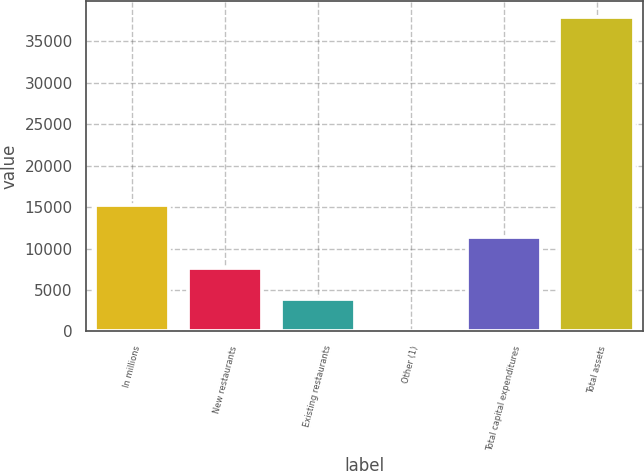Convert chart. <chart><loc_0><loc_0><loc_500><loc_500><bar_chart><fcel>In millions<fcel>New restaurants<fcel>Existing restaurants<fcel>Other (1)<fcel>Total capital expenditures<fcel>Total assets<nl><fcel>15223.6<fcel>7651.8<fcel>3865.9<fcel>80<fcel>11437.7<fcel>37939<nl></chart> 